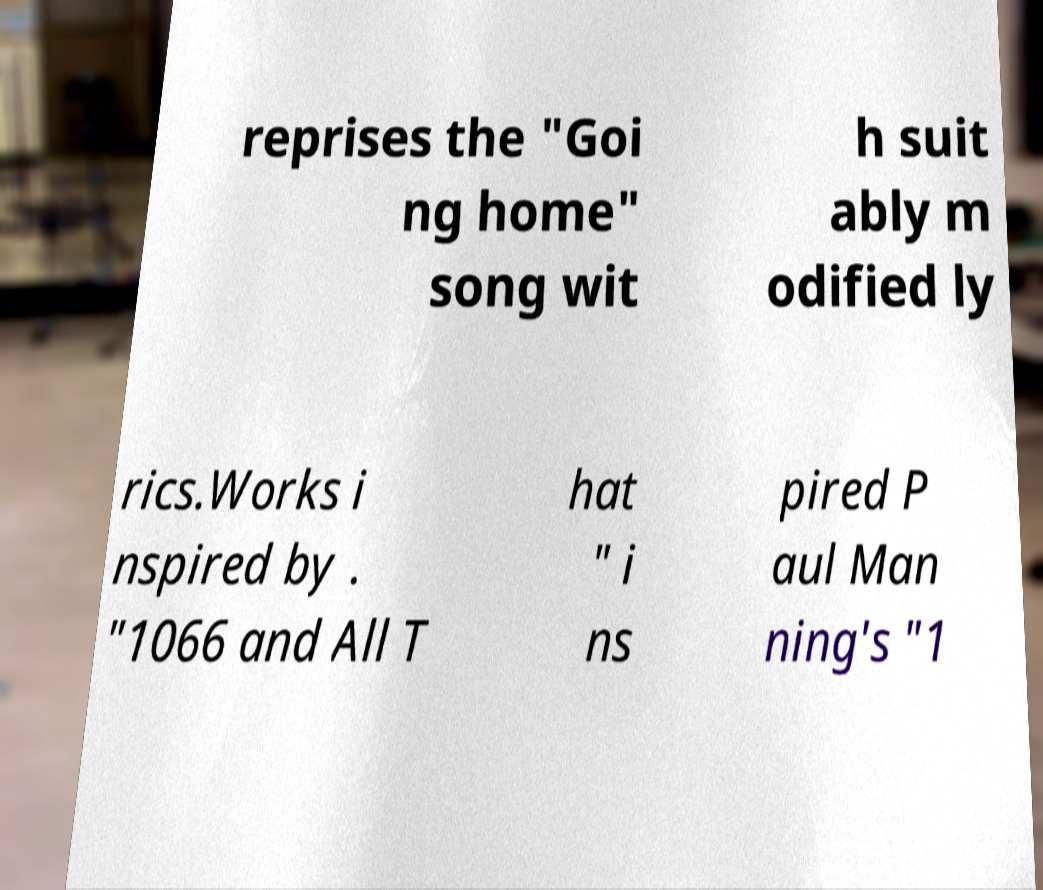Could you extract and type out the text from this image? reprises the "Goi ng home" song wit h suit ably m odified ly rics.Works i nspired by . "1066 and All T hat " i ns pired P aul Man ning's "1 